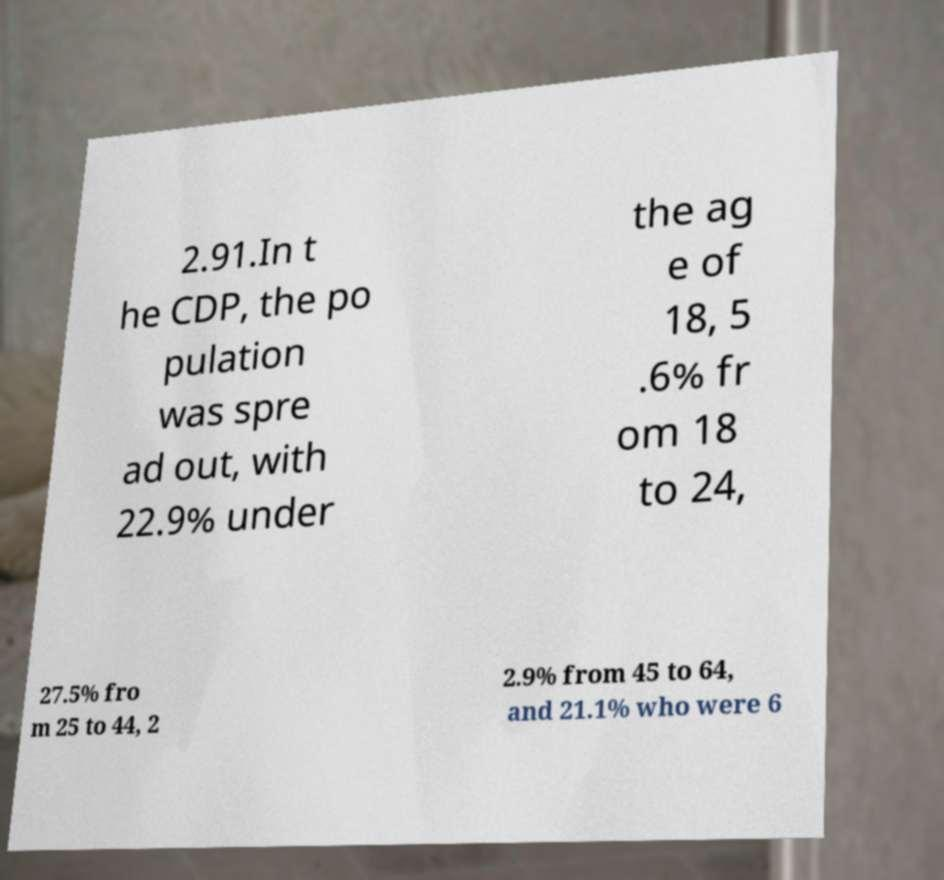Could you extract and type out the text from this image? 2.91.In t he CDP, the po pulation was spre ad out, with 22.9% under the ag e of 18, 5 .6% fr om 18 to 24, 27.5% fro m 25 to 44, 2 2.9% from 45 to 64, and 21.1% who were 6 